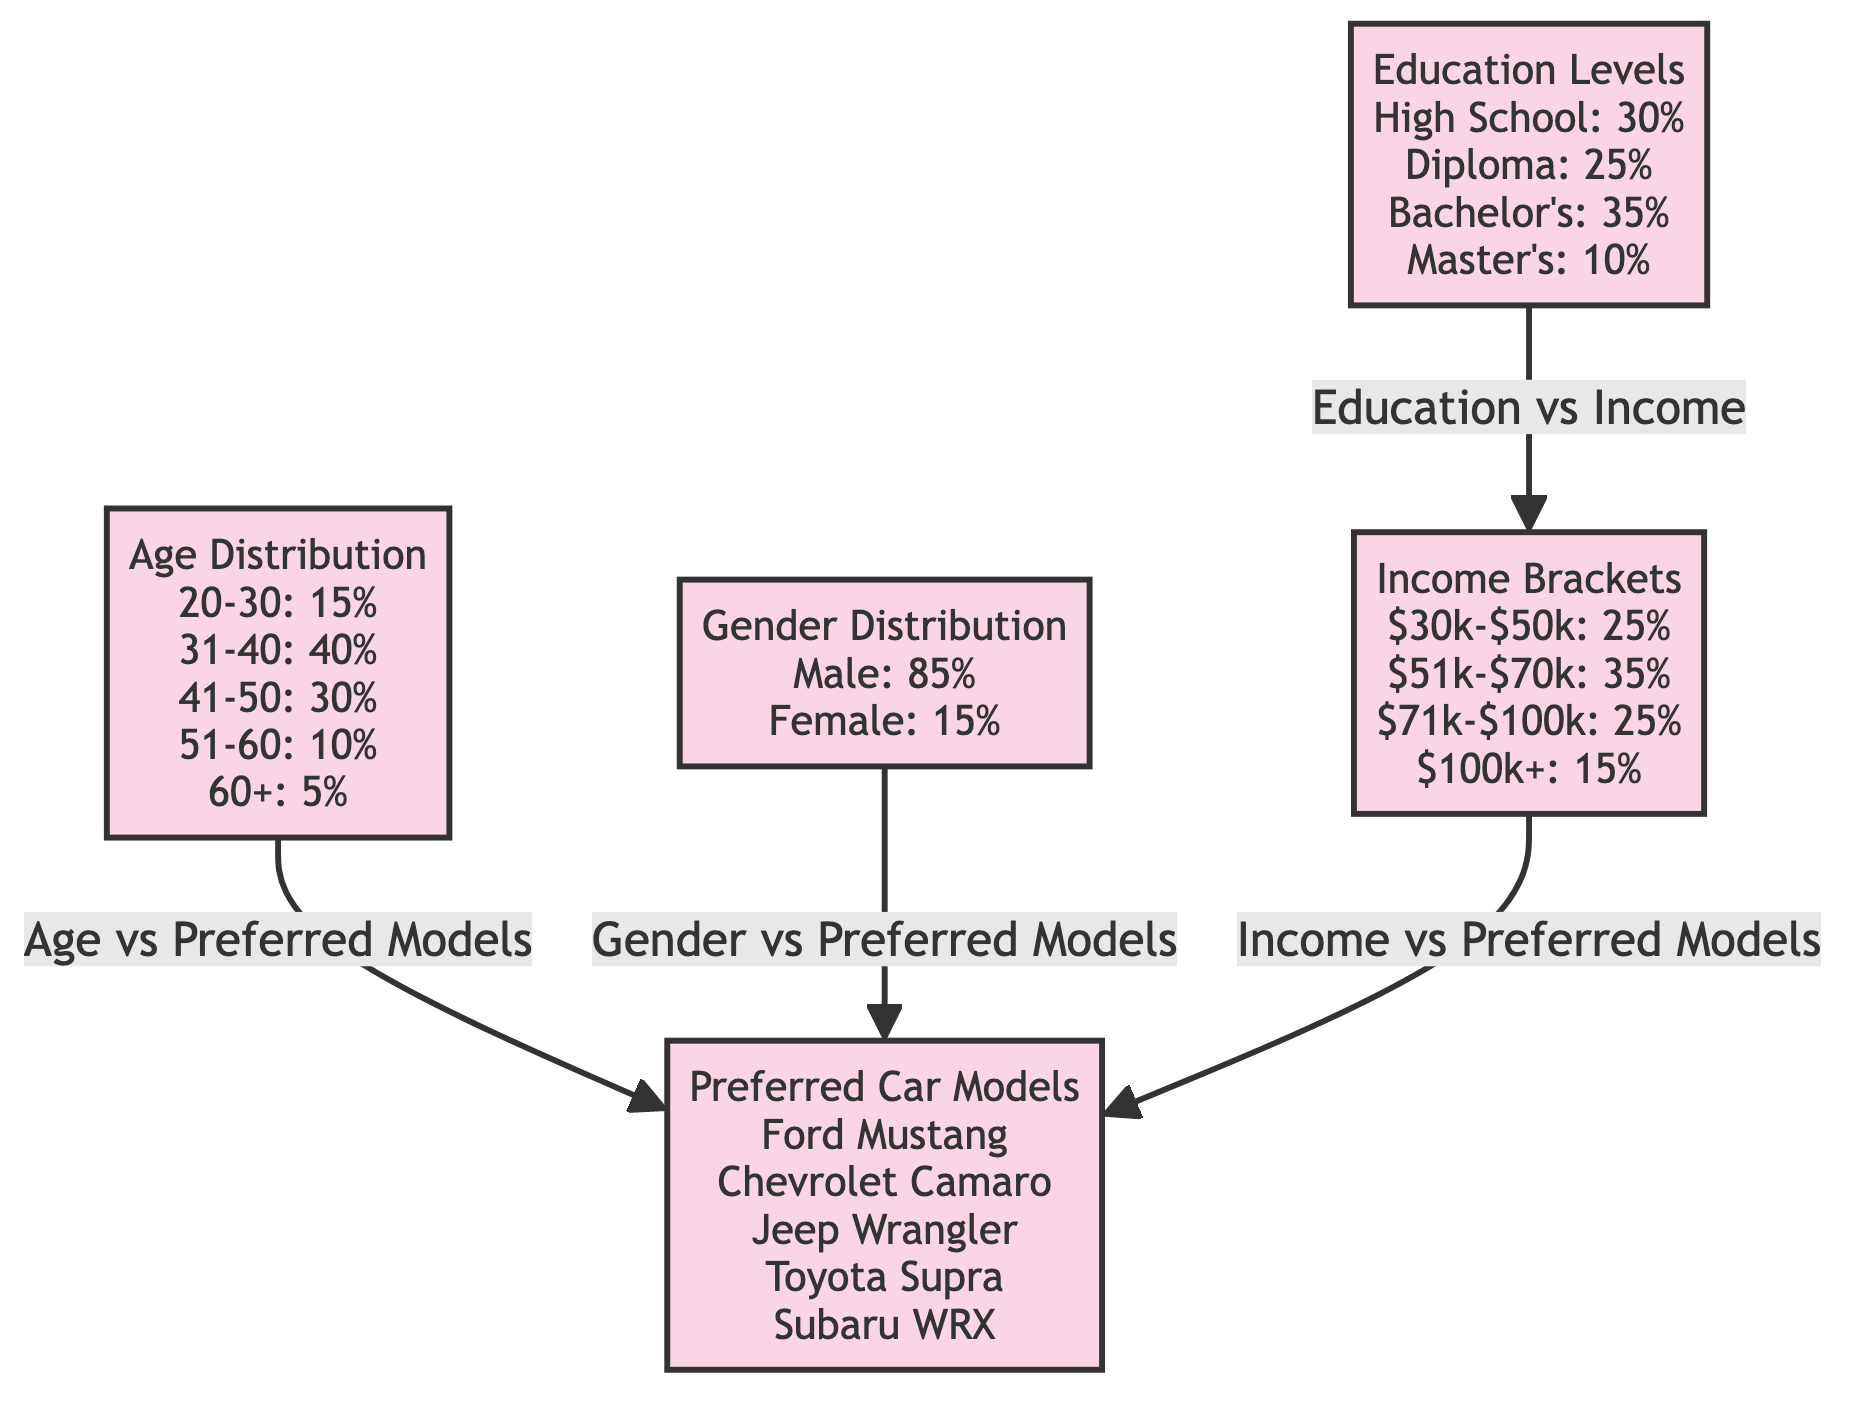What percentage of car enthusiasts are aged 31-40? The diagram shows that the age distribution indicates 40% of car enthusiasts fall into the 31-40 age bracket.
Answer: 40% What is the male-to-female ratio among car enthusiasts in Toronto? The gender distribution shows 85% are male and 15% are female. This results in a ratio of 85:15 or simplified to 17:3.
Answer: 17:3 What level of education has the highest representation among car enthusiasts? According to the education levels in the diagram, 35% have a Bachelor's degree, which is the highest percentage compared to other education levels.
Answer: Bachelor's Which income bracket has the lowest percentage of car enthusiasts? The income brackets listed indicate that the $100k+ category has the lowest representation at 15%, making it the smallest group.
Answer: $100k+ What preferred car model is mentioned in the diagram that starts with 'J'? The list of preferred car models includes the Jeep Wrangler, which is the only model starting with 'J'.
Answer: Jeep Wrangler How does the preferred car model distribution relate to age? The diagram indicates a direct relationship exists where age brackets influence the choice of preferred car models, with specific models being favored in different age ranges. Hence, analyzing the model preferences in relation to age indicates age-based preferences in car selection.
Answer: Age-based preferences What percentage of car enthusiasts have a Master's degree? The education levels data shows that 10% of car enthusiasts have a Master's degree.
Answer: 10% Which preferred car model is most likely chosen by car enthusiasts with an income between $51k-$70k? The diagram indicates that the income bracket of $51k-$70k connects to preferred car models, suggesting specific high-demand models among this income range, but it doesn't specify exactly which model is chosen, requiring a closer look at the model preferences linked to income.
Answer: Not directly specified What total percentage of car enthusiasts earns between $30k and $70k? By adding the two relevant income brackets ($30k-$50k: 25% and $51k-$70k: 35%), the total for those earning between $30k and $70k comes to 60%.
Answer: 60% 